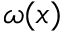<formula> <loc_0><loc_0><loc_500><loc_500>\omega ( x )</formula> 